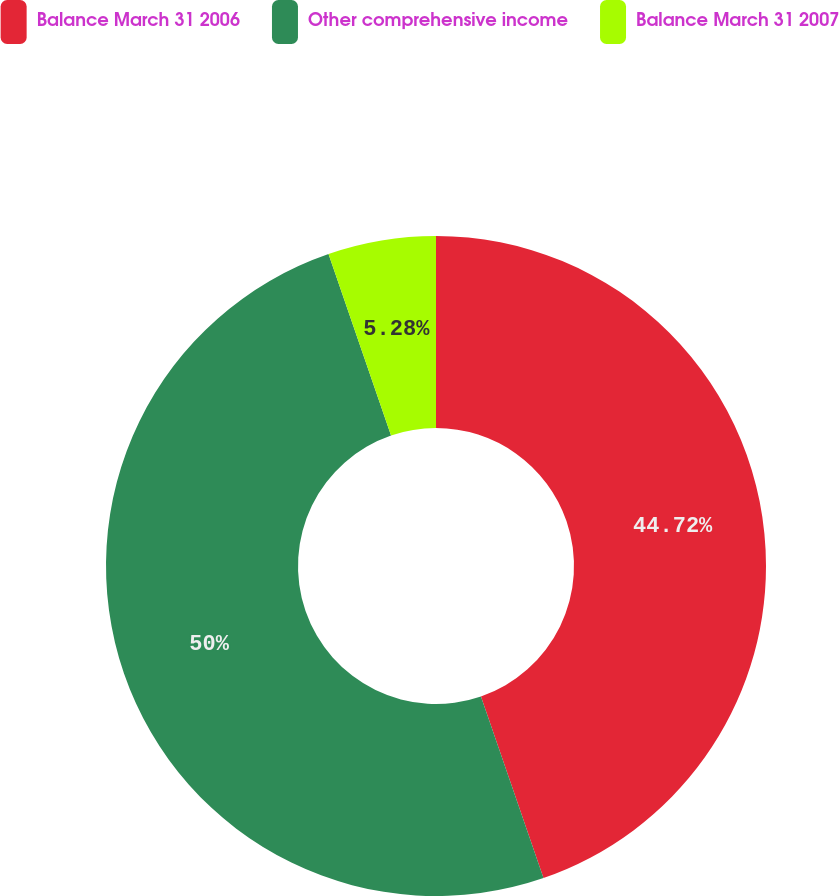Convert chart. <chart><loc_0><loc_0><loc_500><loc_500><pie_chart><fcel>Balance March 31 2006<fcel>Other comprehensive income<fcel>Balance March 31 2007<nl><fcel>44.72%<fcel>50.0%<fcel>5.28%<nl></chart> 